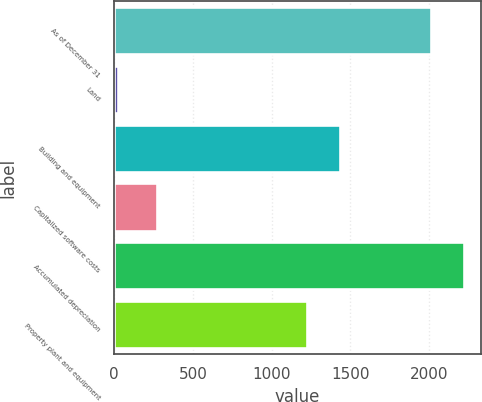Convert chart. <chart><loc_0><loc_0><loc_500><loc_500><bar_chart><fcel>As of December 31<fcel>Land<fcel>Building and equipment<fcel>Capitalized software costs<fcel>Accumulated depreciation<fcel>Property plant and equipment<nl><fcel>2013<fcel>21.7<fcel>1431.68<fcel>272.6<fcel>2219.98<fcel>1224.7<nl></chart> 